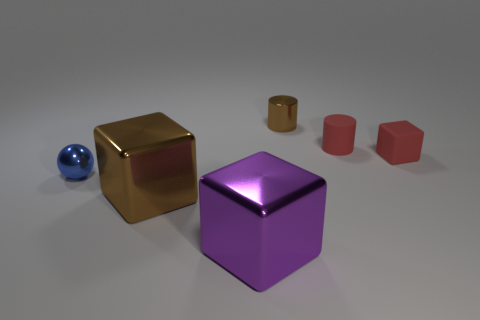Add 1 big blue metallic cylinders. How many objects exist? 7 Subtract all spheres. How many objects are left? 5 Subtract all small things. Subtract all large yellow shiny cylinders. How many objects are left? 2 Add 2 metal things. How many metal things are left? 6 Add 5 tiny cyan rubber cylinders. How many tiny cyan rubber cylinders exist? 5 Subtract 0 green blocks. How many objects are left? 6 